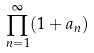<formula> <loc_0><loc_0><loc_500><loc_500>\prod _ { n = 1 } ^ { \infty } ( 1 + a _ { n } )</formula> 